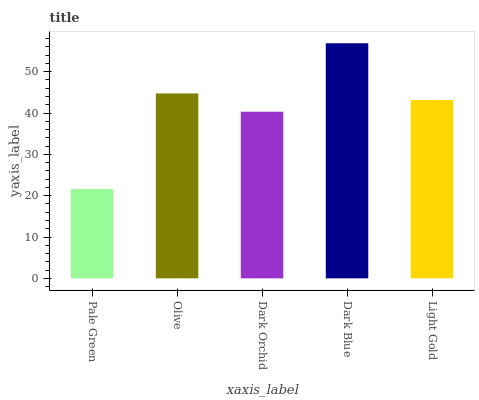Is Pale Green the minimum?
Answer yes or no. Yes. Is Dark Blue the maximum?
Answer yes or no. Yes. Is Olive the minimum?
Answer yes or no. No. Is Olive the maximum?
Answer yes or no. No. Is Olive greater than Pale Green?
Answer yes or no. Yes. Is Pale Green less than Olive?
Answer yes or no. Yes. Is Pale Green greater than Olive?
Answer yes or no. No. Is Olive less than Pale Green?
Answer yes or no. No. Is Light Gold the high median?
Answer yes or no. Yes. Is Light Gold the low median?
Answer yes or no. Yes. Is Olive the high median?
Answer yes or no. No. Is Dark Orchid the low median?
Answer yes or no. No. 